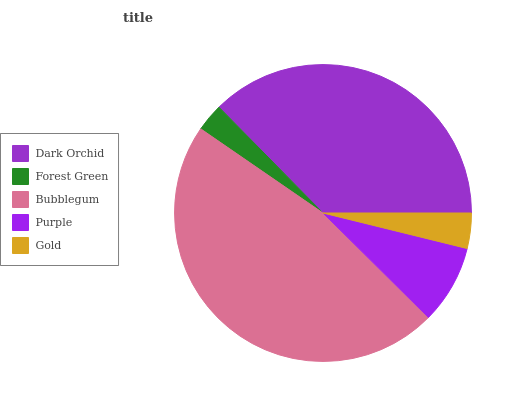Is Forest Green the minimum?
Answer yes or no. Yes. Is Bubblegum the maximum?
Answer yes or no. Yes. Is Bubblegum the minimum?
Answer yes or no. No. Is Forest Green the maximum?
Answer yes or no. No. Is Bubblegum greater than Forest Green?
Answer yes or no. Yes. Is Forest Green less than Bubblegum?
Answer yes or no. Yes. Is Forest Green greater than Bubblegum?
Answer yes or no. No. Is Bubblegum less than Forest Green?
Answer yes or no. No. Is Purple the high median?
Answer yes or no. Yes. Is Purple the low median?
Answer yes or no. Yes. Is Forest Green the high median?
Answer yes or no. No. Is Forest Green the low median?
Answer yes or no. No. 